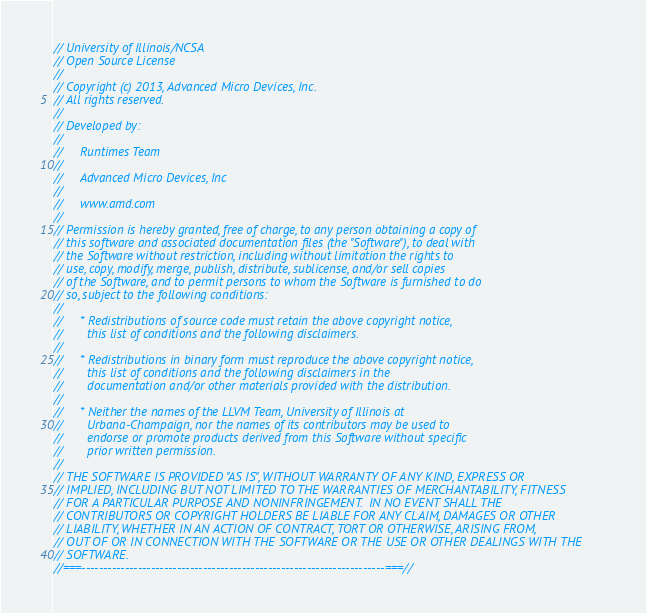Convert code to text. <code><loc_0><loc_0><loc_500><loc_500><_C++_>// University of Illinois/NCSA
// Open Source License
// 
// Copyright (c) 2013, Advanced Micro Devices, Inc.
// All rights reserved.
// 
// Developed by:
// 
//     Runtimes Team
// 
//     Advanced Micro Devices, Inc
// 
//     www.amd.com
// 
// Permission is hereby granted, free of charge, to any person obtaining a copy of
// this software and associated documentation files (the "Software"), to deal with
// the Software without restriction, including without limitation the rights to
// use, copy, modify, merge, publish, distribute, sublicense, and/or sell copies
// of the Software, and to permit persons to whom the Software is furnished to do
// so, subject to the following conditions:
// 
//     * Redistributions of source code must retain the above copyright notice,
//       this list of conditions and the following disclaimers.
// 
//     * Redistributions in binary form must reproduce the above copyright notice,
//       this list of conditions and the following disclaimers in the
//       documentation and/or other materials provided with the distribution.
// 
//     * Neither the names of the LLVM Team, University of Illinois at
//       Urbana-Champaign, nor the names of its contributors may be used to
//       endorse or promote products derived from this Software without specific
//       prior written permission.
// 
// THE SOFTWARE IS PROVIDED "AS IS", WITHOUT WARRANTY OF ANY KIND, EXPRESS OR
// IMPLIED, INCLUDING BUT NOT LIMITED TO THE WARRANTIES OF MERCHANTABILITY, FITNESS
// FOR A PARTICULAR PURPOSE AND NONINFRINGEMENT.  IN NO EVENT SHALL THE
// CONTRIBUTORS OR COPYRIGHT HOLDERS BE LIABLE FOR ANY CLAIM, DAMAGES OR OTHER
// LIABILITY, WHETHER IN AN ACTION OF CONTRACT, TORT OR OTHERWISE, ARISING FROM,
// OUT OF OR IN CONNECTION WITH THE SOFTWARE OR THE USE OR OTHER DEALINGS WITH THE
// SOFTWARE.
//===----------------------------------------------------------------------===//
</code> 